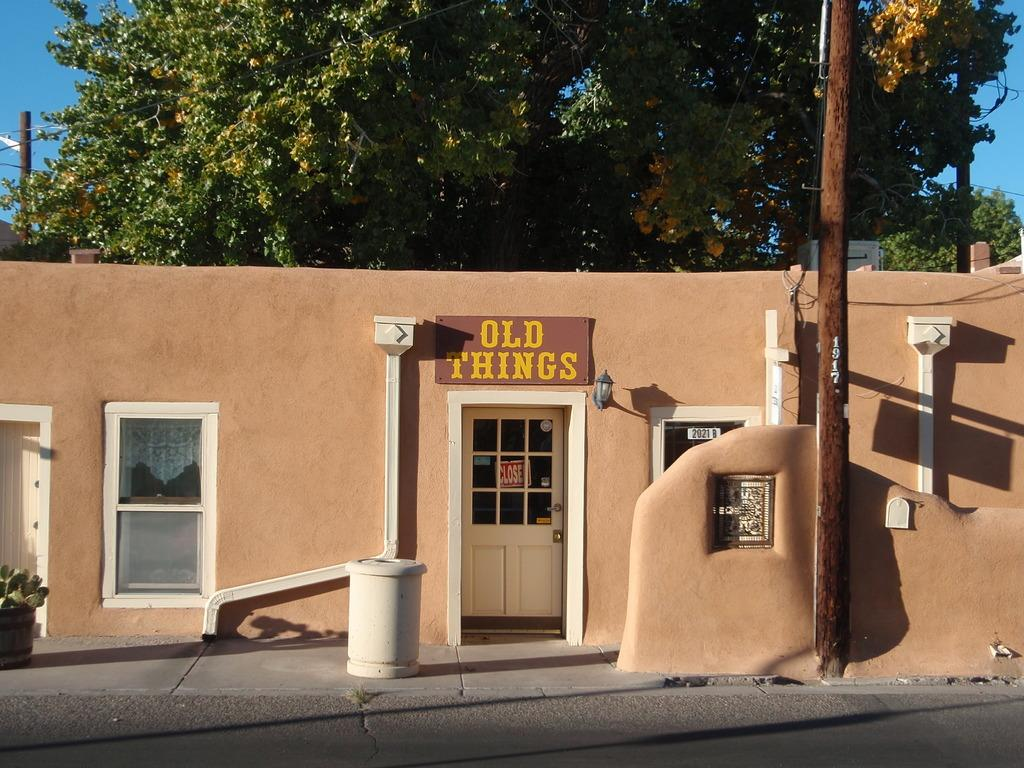What type of outdoor surface can be seen in the image? There is a road in the image. What architectural feature is present in the image? There is a door in the image. What type of plant is visible in the image? There is a house plant in the image. What signage can be seen in the image? There are name boards in the image. What allows natural light to enter the building in the image? There are windows in the image. What structural elements are present in the image? There are walls in the image. What vertical structures are present in the image? There are poles in the image. What type of vegetation is visible in the image? There are trees in the image. What additional objects can be seen in the image? There are some objects in the image. What can be seen in the background of the image? The sky is visible in the background of the image. How many roses are on the windowsill in the image? There are no roses visible in the image. What type of operation is being performed on the house in the image? There is no operation being performed on the house in the image. How many pizzas are being delivered to the house in the image? There is no indication of pizza delivery in the image. 